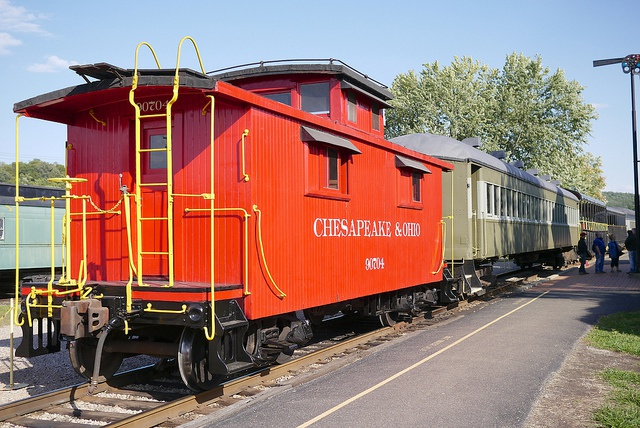Describe the objects in this image and their specific colors. I can see train in lavender, red, black, and gray tones, people in lavender, black, navy, and gray tones, people in lavender, black, gray, and maroon tones, people in lavender, black, navy, gray, and darkblue tones, and people in lavender, black, navy, darkblue, and gray tones in this image. 